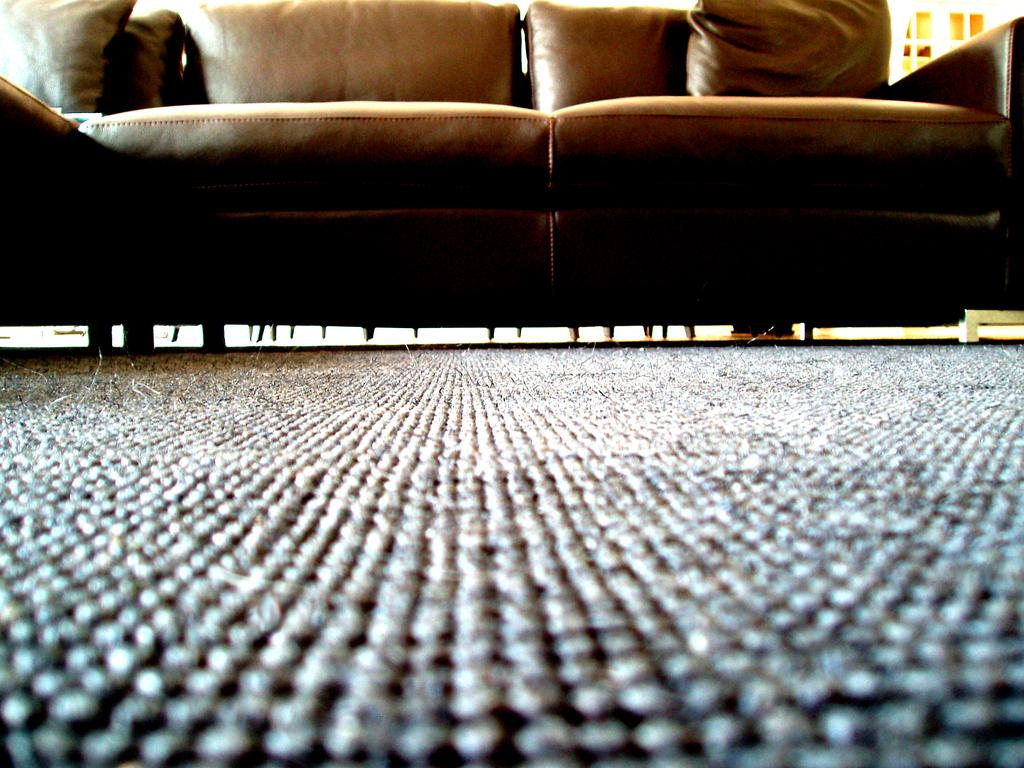What type of furniture is present in the image? There is a brown-colored sofa in the image. What is on the floor in the image? There is a mat on the floor in the image. What type of chalk is visible on the brown-colored sofa in the image? There is no chalk present on the brown-colored sofa in the image. How many fowls are sitting on the mat in the image? There are no fowls present in the image, so it is not possible to determine how many would be sitting on the mat. 